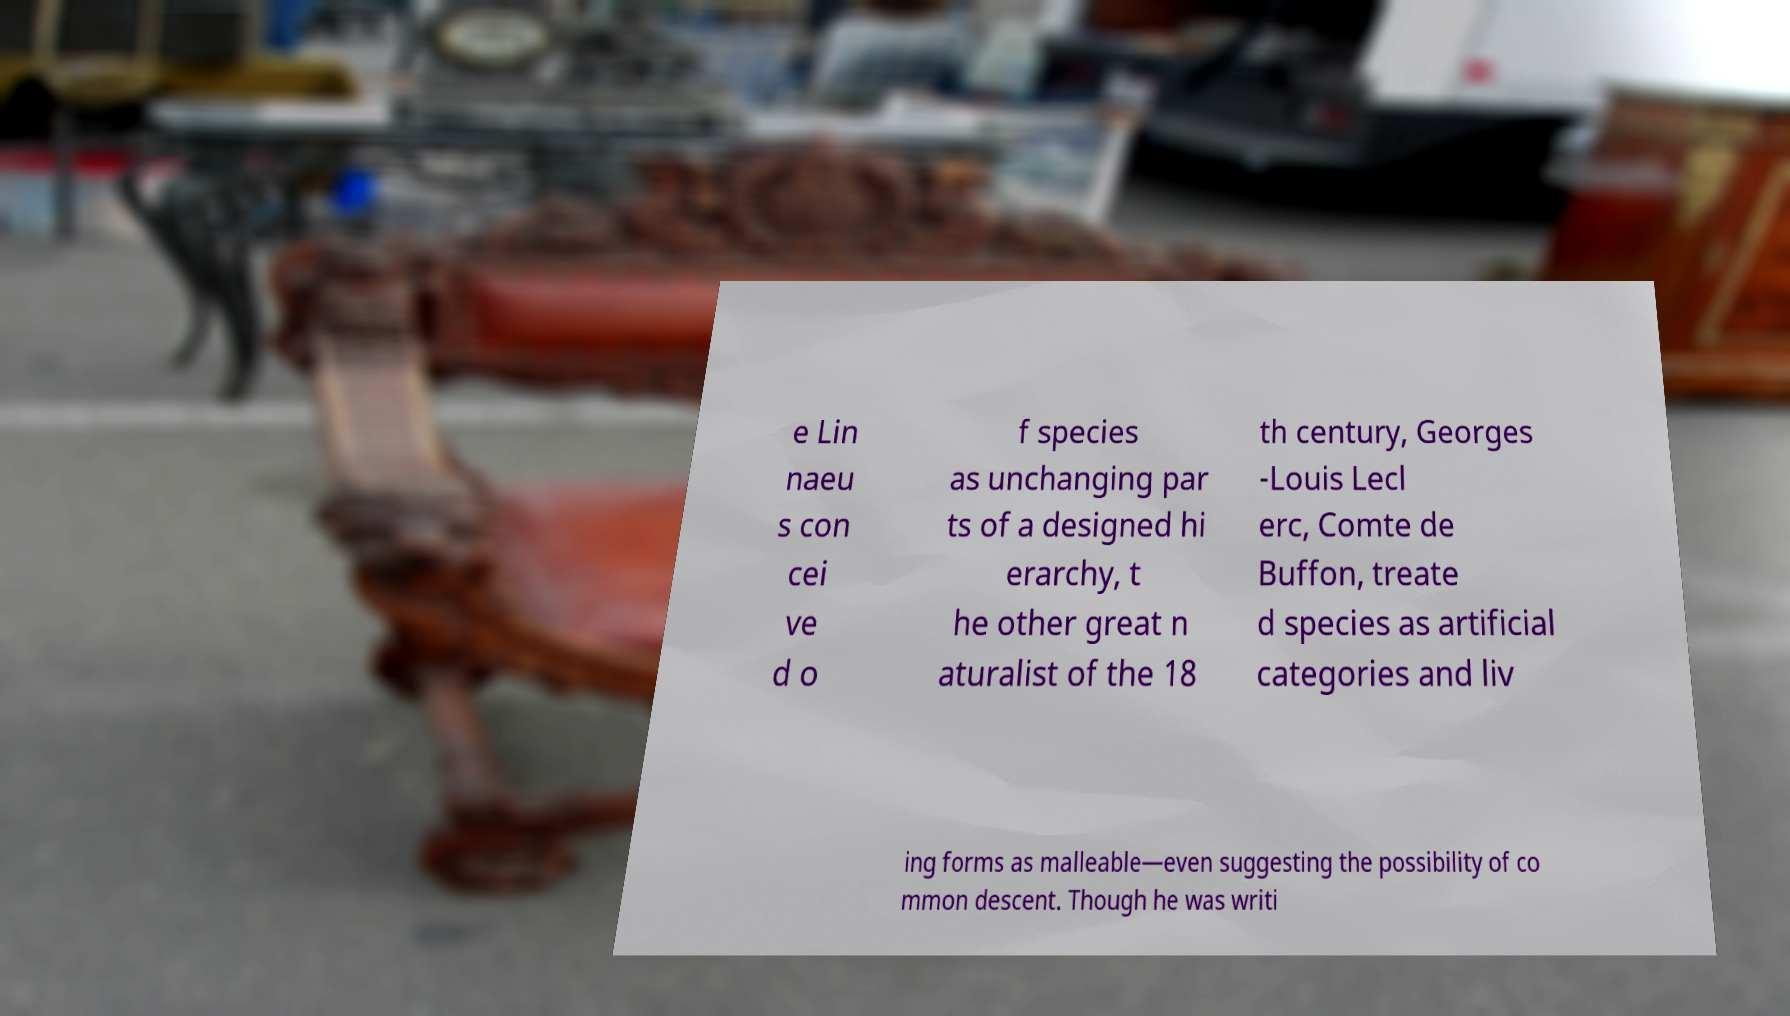Can you accurately transcribe the text from the provided image for me? e Lin naeu s con cei ve d o f species as unchanging par ts of a designed hi erarchy, t he other great n aturalist of the 18 th century, Georges -Louis Lecl erc, Comte de Buffon, treate d species as artificial categories and liv ing forms as malleable—even suggesting the possibility of co mmon descent. Though he was writi 